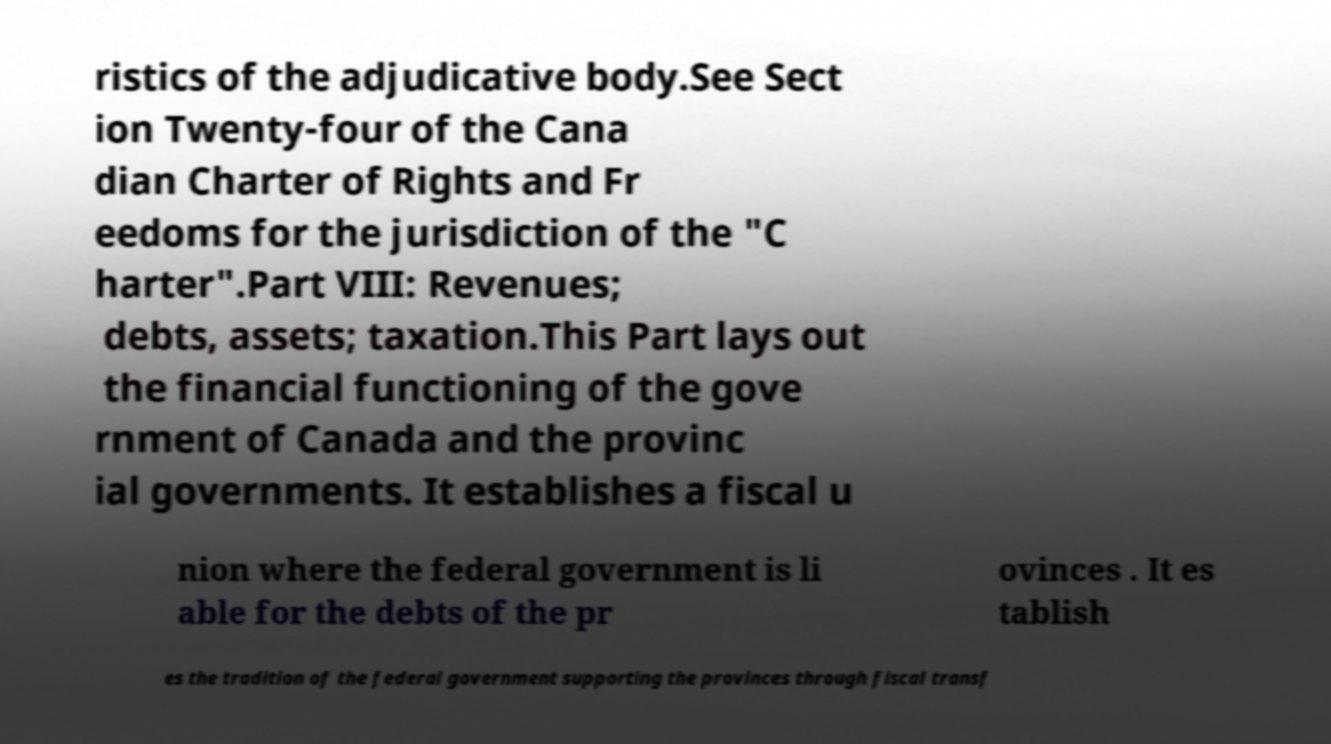Can you accurately transcribe the text from the provided image for me? ristics of the adjudicative body.See Sect ion Twenty-four of the Cana dian Charter of Rights and Fr eedoms for the jurisdiction of the "C harter".Part VIII: Revenues; debts, assets; taxation.This Part lays out the financial functioning of the gove rnment of Canada and the provinc ial governments. It establishes a fiscal u nion where the federal government is li able for the debts of the pr ovinces . It es tablish es the tradition of the federal government supporting the provinces through fiscal transf 